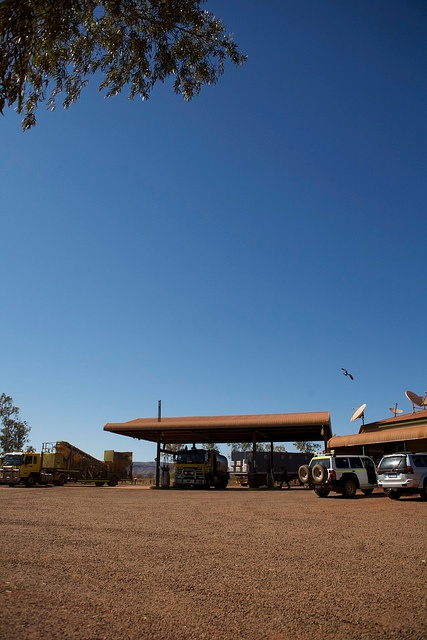Describe the objects in this image and their specific colors. I can see truck in darkblue, black, gray, maroon, and olive tones, truck in darkblue, black, gray, maroon, and darkgray tones, car in darkblue, black, gray, darkgray, and maroon tones, truck in darkblue, black, maroon, olive, and gray tones, and truck in darkblue, black, and gray tones in this image. 